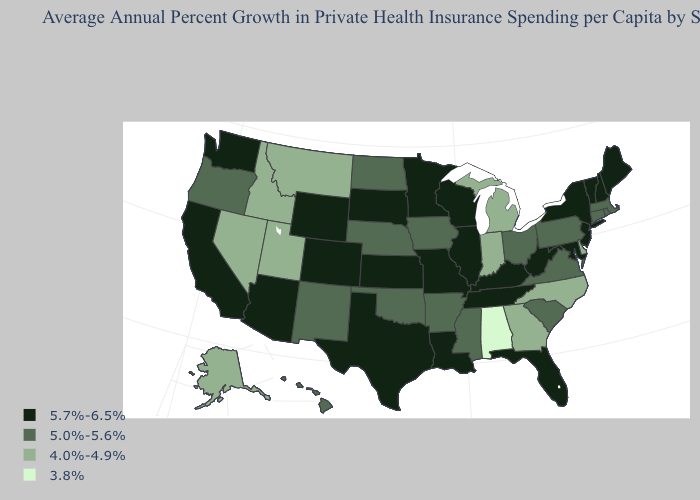What is the value of Nevada?
Keep it brief. 4.0%-4.9%. Name the states that have a value in the range 5.7%-6.5%?
Answer briefly. Arizona, California, Colorado, Florida, Illinois, Kansas, Kentucky, Louisiana, Maine, Maryland, Minnesota, Missouri, New Hampshire, New Jersey, New York, South Dakota, Tennessee, Texas, Vermont, Washington, West Virginia, Wisconsin, Wyoming. What is the value of Missouri?
Write a very short answer. 5.7%-6.5%. What is the value of Virginia?
Be succinct. 5.0%-5.6%. Name the states that have a value in the range 3.8%?
Short answer required. Alabama. Does Wisconsin have the highest value in the USA?
Answer briefly. Yes. Does North Dakota have a higher value than Kansas?
Concise answer only. No. Among the states that border Tennessee , which have the lowest value?
Keep it brief. Alabama. Among the states that border Oklahoma , does Texas have the lowest value?
Be succinct. No. Which states hav the highest value in the MidWest?
Be succinct. Illinois, Kansas, Minnesota, Missouri, South Dakota, Wisconsin. Among the states that border Oregon , which have the lowest value?
Give a very brief answer. Idaho, Nevada. What is the value of Arkansas?
Answer briefly. 5.0%-5.6%. Does Illinois have a lower value than West Virginia?
Answer briefly. No. What is the value of Arizona?
Be succinct. 5.7%-6.5%. Among the states that border Missouri , does Iowa have the lowest value?
Be succinct. Yes. 